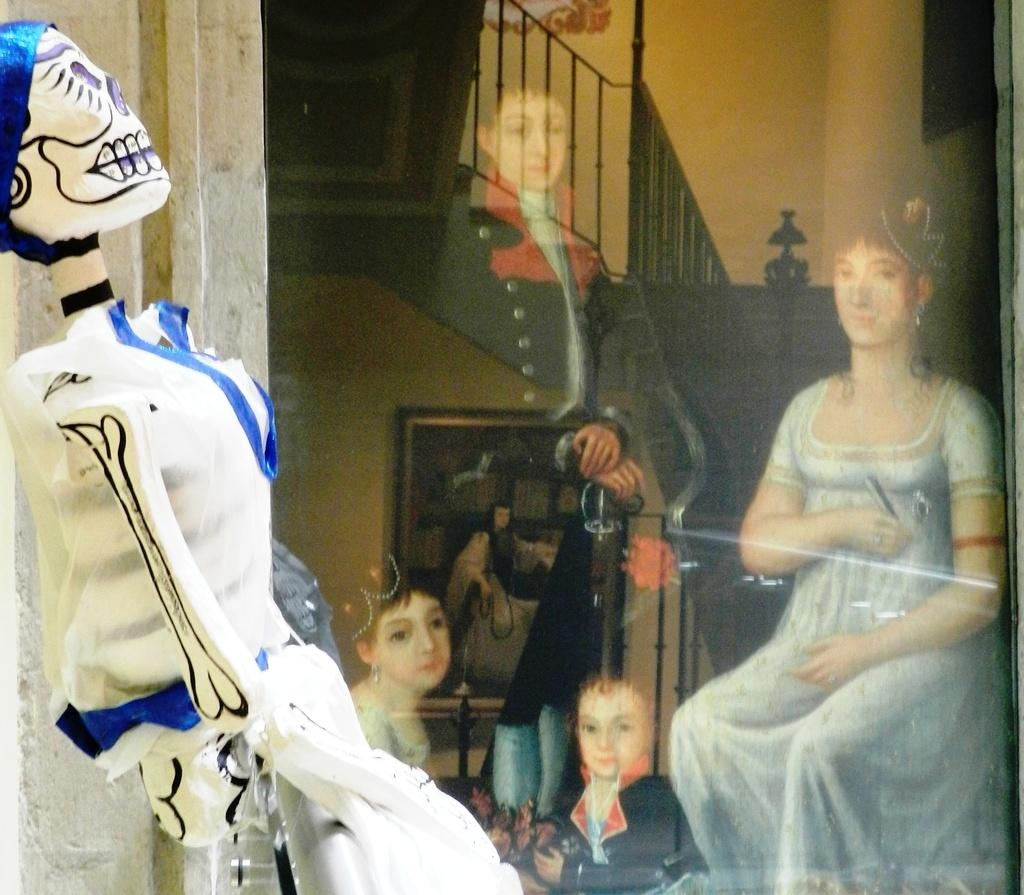What is the main subject of the image? There is a sculpture in the image. What does the sculpture depict? The sculpture depicts people. What architectural feature is present in the image? There are stairs in the image. What safety feature is present in the image? There is a railing in the image. What type of structure is visible in the image? There is a wall in the image. What type of enclosure is present in the image? There is a frame in the image. Where is the nest located in the image? There is no nest present in the image. What type of cup is being used by the people in the sculpture? The sculpture does not depict people using a cup; it only shows the figures themselves. 